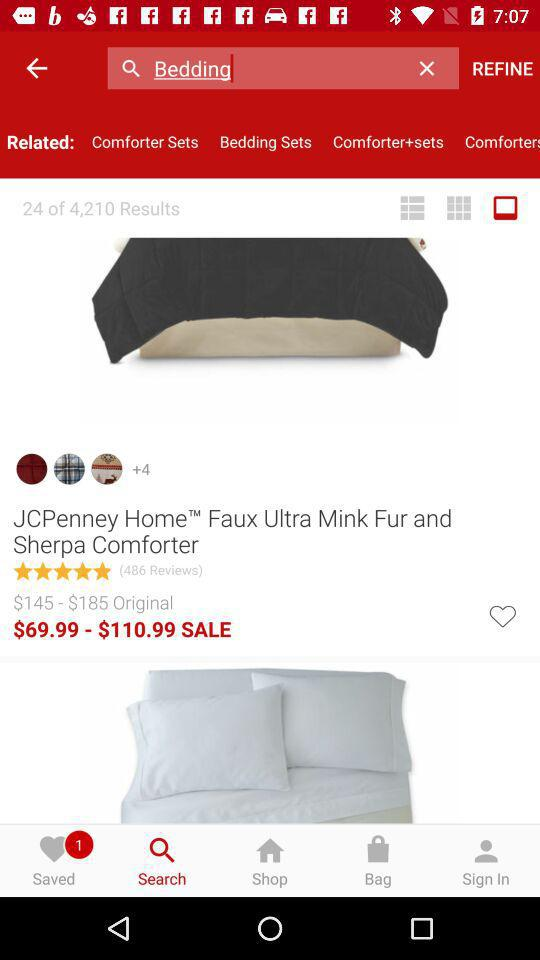How much is the product on sale for?
Answer the question using a single word or phrase. $69.99 - $110.99 